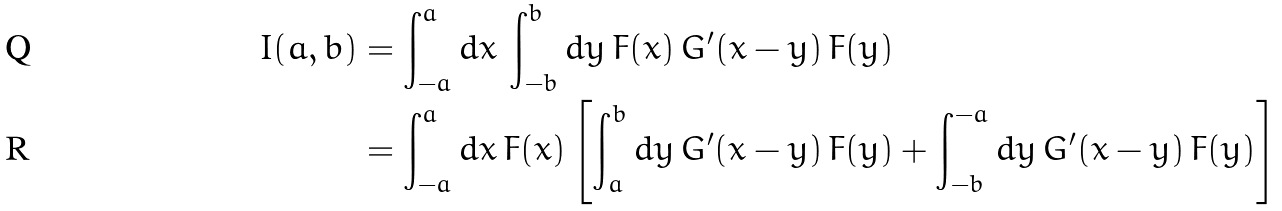Convert formula to latex. <formula><loc_0><loc_0><loc_500><loc_500>I ( a , b ) & = \int _ { - a } ^ { a } d x \, \int _ { - b } ^ { b } d y \, F ( x ) \, G ^ { \prime } ( x - y ) \, F ( y ) \\ & = \int _ { - a } ^ { a } d x \, F ( x ) \left [ \int _ { a } ^ { b } d y \, G ^ { \prime } ( x - y ) \, F ( y ) + \int _ { - b } ^ { - a } d y \, G ^ { \prime } ( x - y ) \, F ( y ) \right ]</formula> 